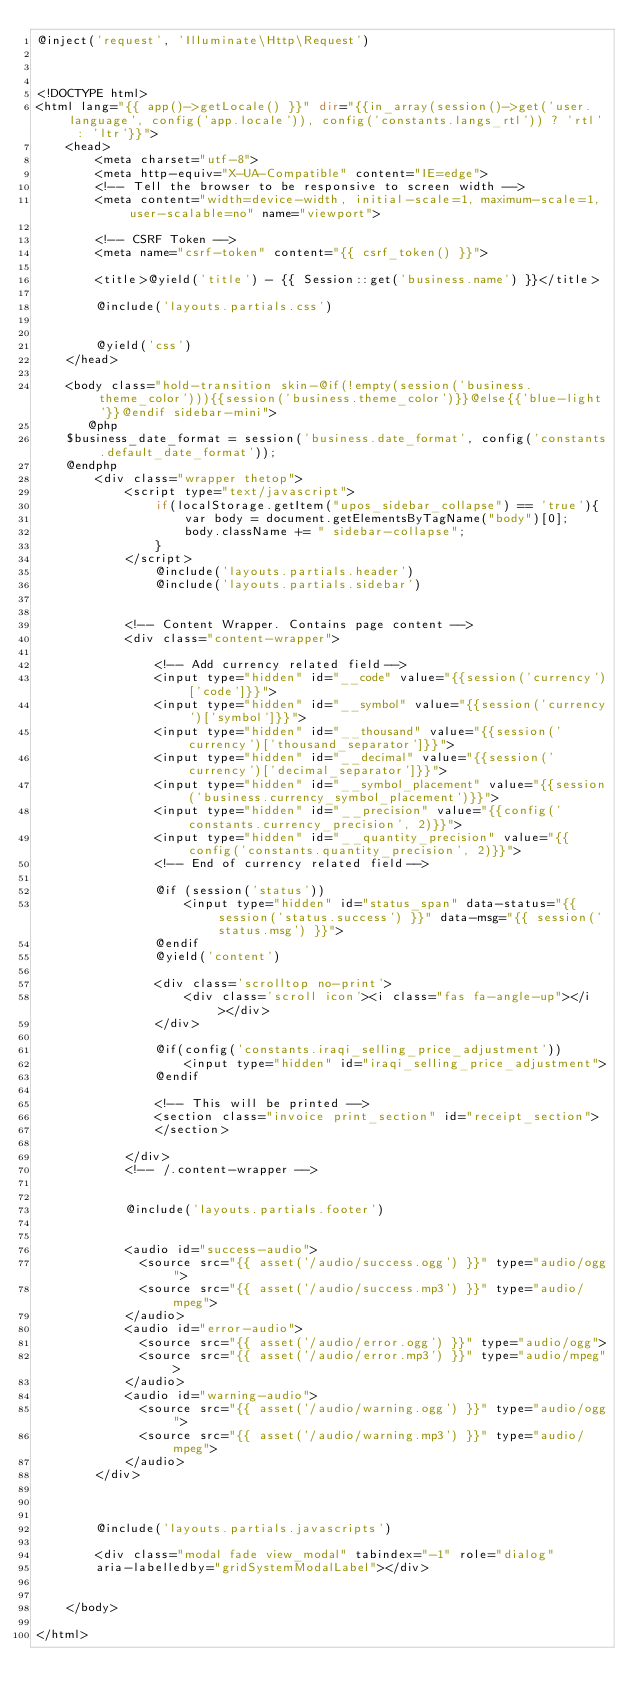Convert code to text. <code><loc_0><loc_0><loc_500><loc_500><_PHP_>@inject('request', 'Illuminate\Http\Request')



<!DOCTYPE html>
<html lang="{{ app()->getLocale() }}" dir="{{in_array(session()->get('user.language', config('app.locale')), config('constants.langs_rtl')) ? 'rtl' : 'ltr'}}">
    <head>
        <meta charset="utf-8">
        <meta http-equiv="X-UA-Compatible" content="IE=edge">
        <!-- Tell the browser to be responsive to screen width -->
        <meta content="width=device-width, initial-scale=1, maximum-scale=1, user-scalable=no" name="viewport">

        <!-- CSRF Token -->
        <meta name="csrf-token" content="{{ csrf_token() }}">

        <title>@yield('title') - {{ Session::get('business.name') }}</title>
        
        @include('layouts.partials.css')
       

        @yield('css')
    </head>

    <body class="hold-transition skin-@if(!empty(session('business.theme_color'))){{session('business.theme_color')}}@else{{'blue-light'}}@endif sidebar-mini">
       @php
    $business_date_format = session('business.date_format', config('constants.default_date_format'));
    @endphp
        <div class="wrapper thetop">
            <script type="text/javascript">
                if(localStorage.getItem("upos_sidebar_collapse") == 'true'){
                    var body = document.getElementsByTagName("body")[0];
                    body.className += " sidebar-collapse";
                }
            </script>
                @include('layouts.partials.header')
                @include('layouts.partials.sidebar')
           

            <!-- Content Wrapper. Contains page content -->
            <div class="content-wrapper">
                
                <!-- Add currency related field-->
                <input type="hidden" id="__code" value="{{session('currency')['code']}}">
                <input type="hidden" id="__symbol" value="{{session('currency')['symbol']}}">
                <input type="hidden" id="__thousand" value="{{session('currency')['thousand_separator']}}">
                <input type="hidden" id="__decimal" value="{{session('currency')['decimal_separator']}}">
                <input type="hidden" id="__symbol_placement" value="{{session('business.currency_symbol_placement')}}">
                <input type="hidden" id="__precision" value="{{config('constants.currency_precision', 2)}}">
                <input type="hidden" id="__quantity_precision" value="{{config('constants.quantity_precision', 2)}}">
                <!-- End of currency related field-->

                @if (session('status'))
                    <input type="hidden" id="status_span" data-status="{{ session('status.success') }}" data-msg="{{ session('status.msg') }}">
                @endif
                @yield('content')

                <div class='scrolltop no-print'>
                    <div class='scroll icon'><i class="fas fa-angle-up"></i></div>
                </div>

                @if(config('constants.iraqi_selling_price_adjustment'))
                    <input type="hidden" id="iraqi_selling_price_adjustment">
                @endif

                <!-- This will be printed -->
                <section class="invoice print_section" id="receipt_section">
                </section>
                
            </div>
            <!-- /.content-wrapper -->

           
            @include('layouts.partials.footer')
            

            <audio id="success-audio">
              <source src="{{ asset('/audio/success.ogg') }}" type="audio/ogg">
              <source src="{{ asset('/audio/success.mp3') }}" type="audio/mpeg">
            </audio>
            <audio id="error-audio">
              <source src="{{ asset('/audio/error.ogg') }}" type="audio/ogg">
              <source src="{{ asset('/audio/error.mp3') }}" type="audio/mpeg">
            </audio>
            <audio id="warning-audio">
              <source src="{{ asset('/audio/warning.ogg') }}" type="audio/ogg">
              <source src="{{ asset('/audio/warning.mp3') }}" type="audio/mpeg">
            </audio>
        </div>

     

        @include('layouts.partials.javascripts')

        <div class="modal fade view_modal" tabindex="-1" role="dialog" 
        aria-labelledby="gridSystemModalLabel"></div>

      
    </body>

</html></code> 